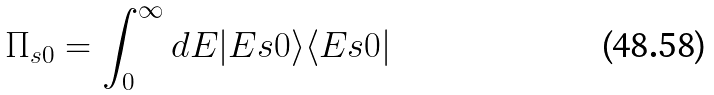Convert formula to latex. <formula><loc_0><loc_0><loc_500><loc_500>\Pi _ { s 0 } = \int _ { 0 } ^ { \infty } d E | E s 0 \rangle \langle E s 0 |</formula> 